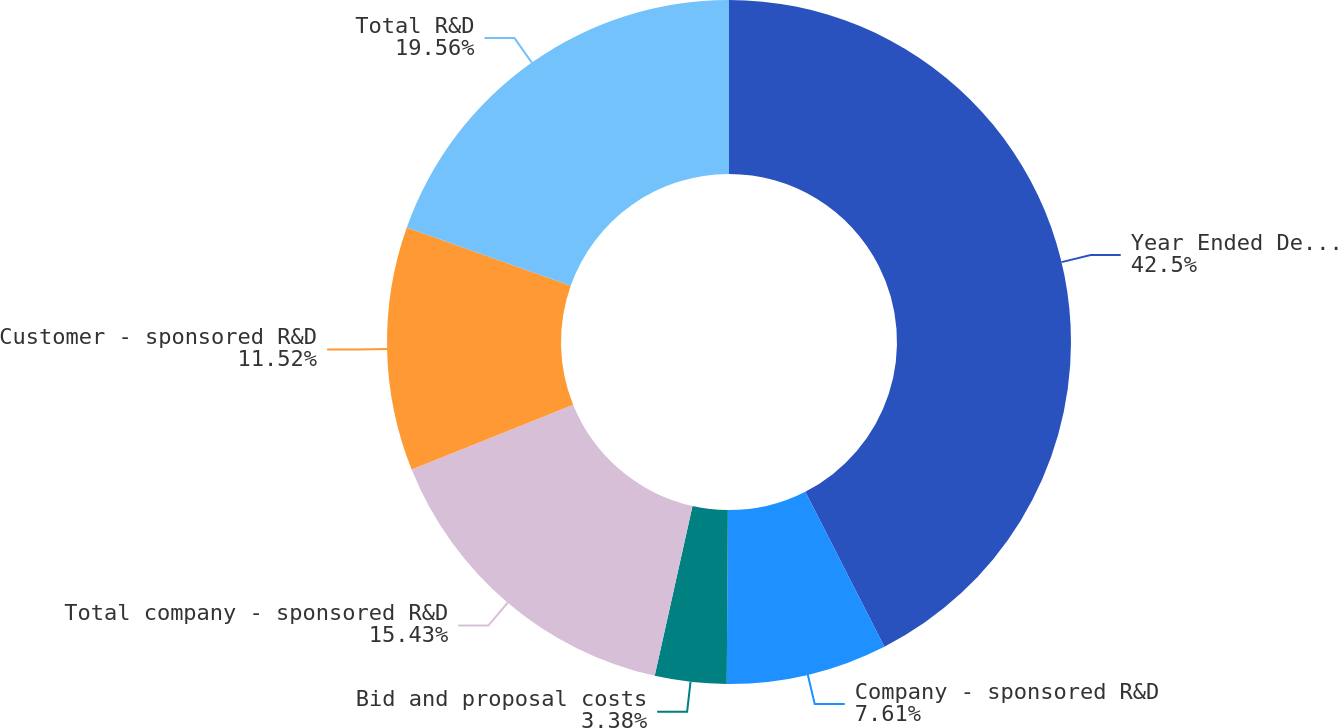<chart> <loc_0><loc_0><loc_500><loc_500><pie_chart><fcel>Year Ended December 31<fcel>Company - sponsored R&D<fcel>Bid and proposal costs<fcel>Total company - sponsored R&D<fcel>Customer - sponsored R&D<fcel>Total R&D<nl><fcel>42.49%<fcel>7.61%<fcel>3.38%<fcel>15.43%<fcel>11.52%<fcel>19.56%<nl></chart> 